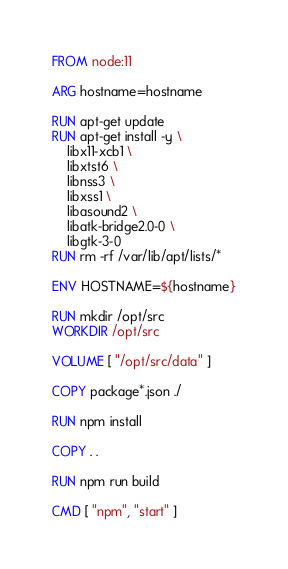<code> <loc_0><loc_0><loc_500><loc_500><_Dockerfile_>FROM node:11

ARG hostname=hostname

RUN apt-get update
RUN apt-get install -y \
	libx11-xcb1 \
	libxtst6 \
	libnss3 \
	libxss1 \
	libasound2 \
	libatk-bridge2.0-0 \
	libgtk-3-0
RUN rm -rf /var/lib/apt/lists/*

ENV HOSTNAME=${hostname}

RUN mkdir /opt/src
WORKDIR /opt/src

VOLUME [ "/opt/src/data" ]

COPY package*.json ./

RUN npm install

COPY . .

RUN npm run build

CMD [ "npm", "start" ]
</code> 